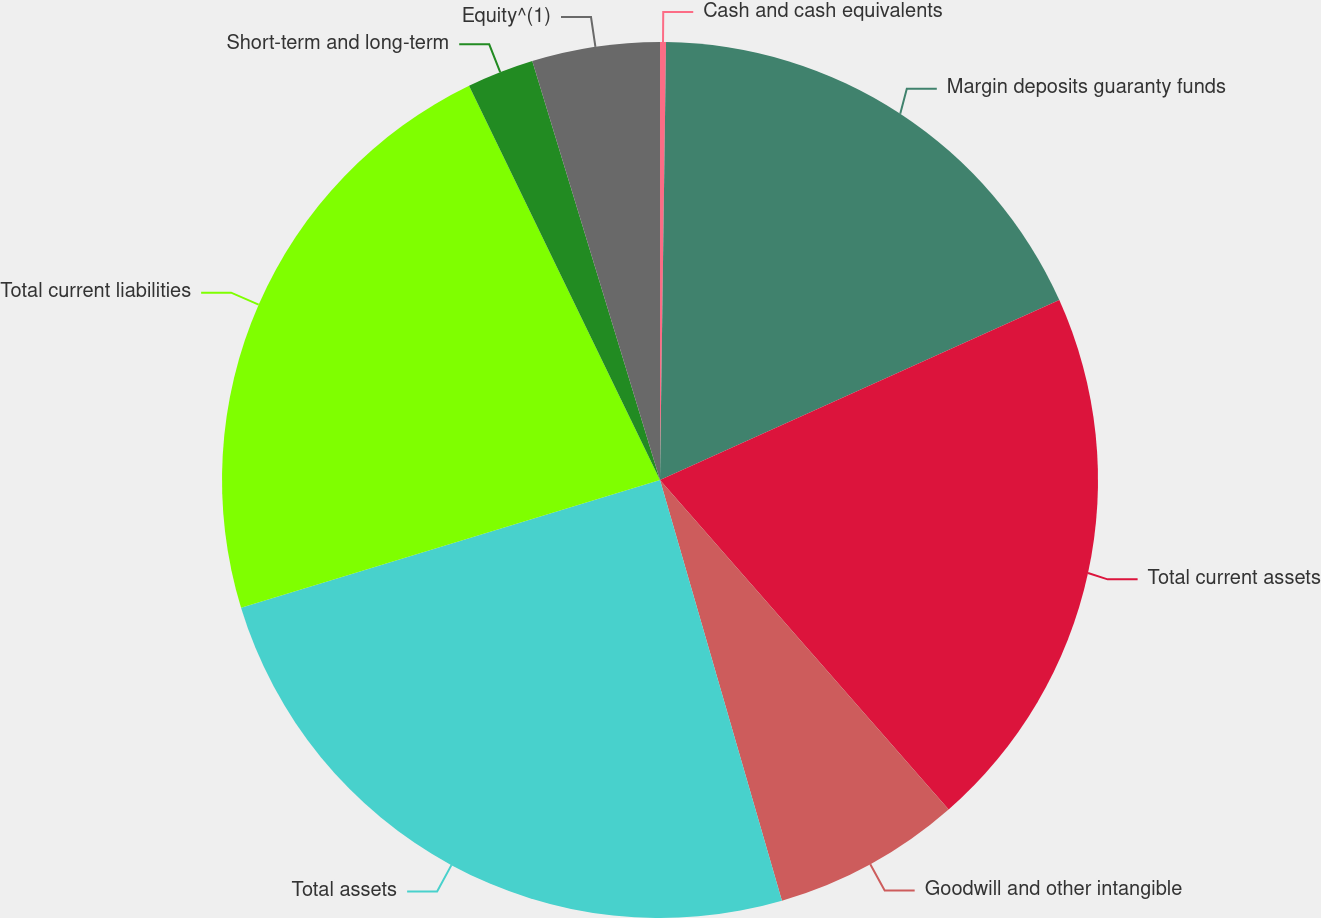<chart> <loc_0><loc_0><loc_500><loc_500><pie_chart><fcel>Cash and cash equivalents<fcel>Margin deposits guaranty funds<fcel>Total current assets<fcel>Goodwill and other intangible<fcel>Total assets<fcel>Total current liabilities<fcel>Short-term and long-term<fcel>Equity^(1)<nl><fcel>0.22%<fcel>18.04%<fcel>20.29%<fcel>6.96%<fcel>24.78%<fcel>22.53%<fcel>2.47%<fcel>4.71%<nl></chart> 